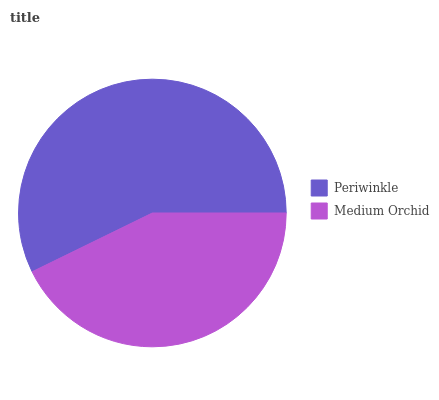Is Medium Orchid the minimum?
Answer yes or no. Yes. Is Periwinkle the maximum?
Answer yes or no. Yes. Is Medium Orchid the maximum?
Answer yes or no. No. Is Periwinkle greater than Medium Orchid?
Answer yes or no. Yes. Is Medium Orchid less than Periwinkle?
Answer yes or no. Yes. Is Medium Orchid greater than Periwinkle?
Answer yes or no. No. Is Periwinkle less than Medium Orchid?
Answer yes or no. No. Is Periwinkle the high median?
Answer yes or no. Yes. Is Medium Orchid the low median?
Answer yes or no. Yes. Is Medium Orchid the high median?
Answer yes or no. No. Is Periwinkle the low median?
Answer yes or no. No. 